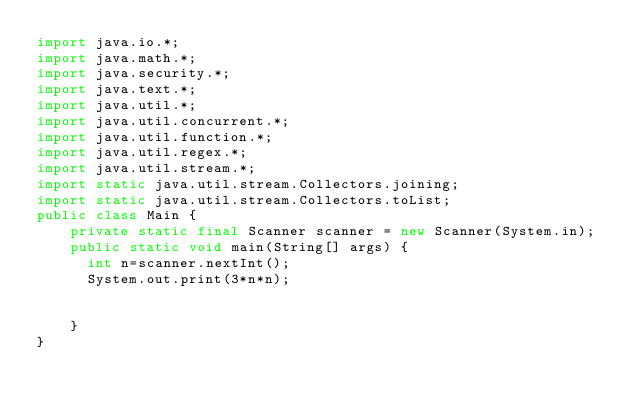<code> <loc_0><loc_0><loc_500><loc_500><_Java_>import java.io.*;
import java.math.*;
import java.security.*;
import java.text.*;
import java.util.*;
import java.util.concurrent.*;
import java.util.function.*;
import java.util.regex.*;
import java.util.stream.*;
import static java.util.stream.Collectors.joining;
import static java.util.stream.Collectors.toList;
public class Main {
    private static final Scanner scanner = new Scanner(System.in);
    public static void main(String[] args) {
      int n=scanner.nextInt();
      System.out.print(3*n*n);
      
        
    }
}</code> 